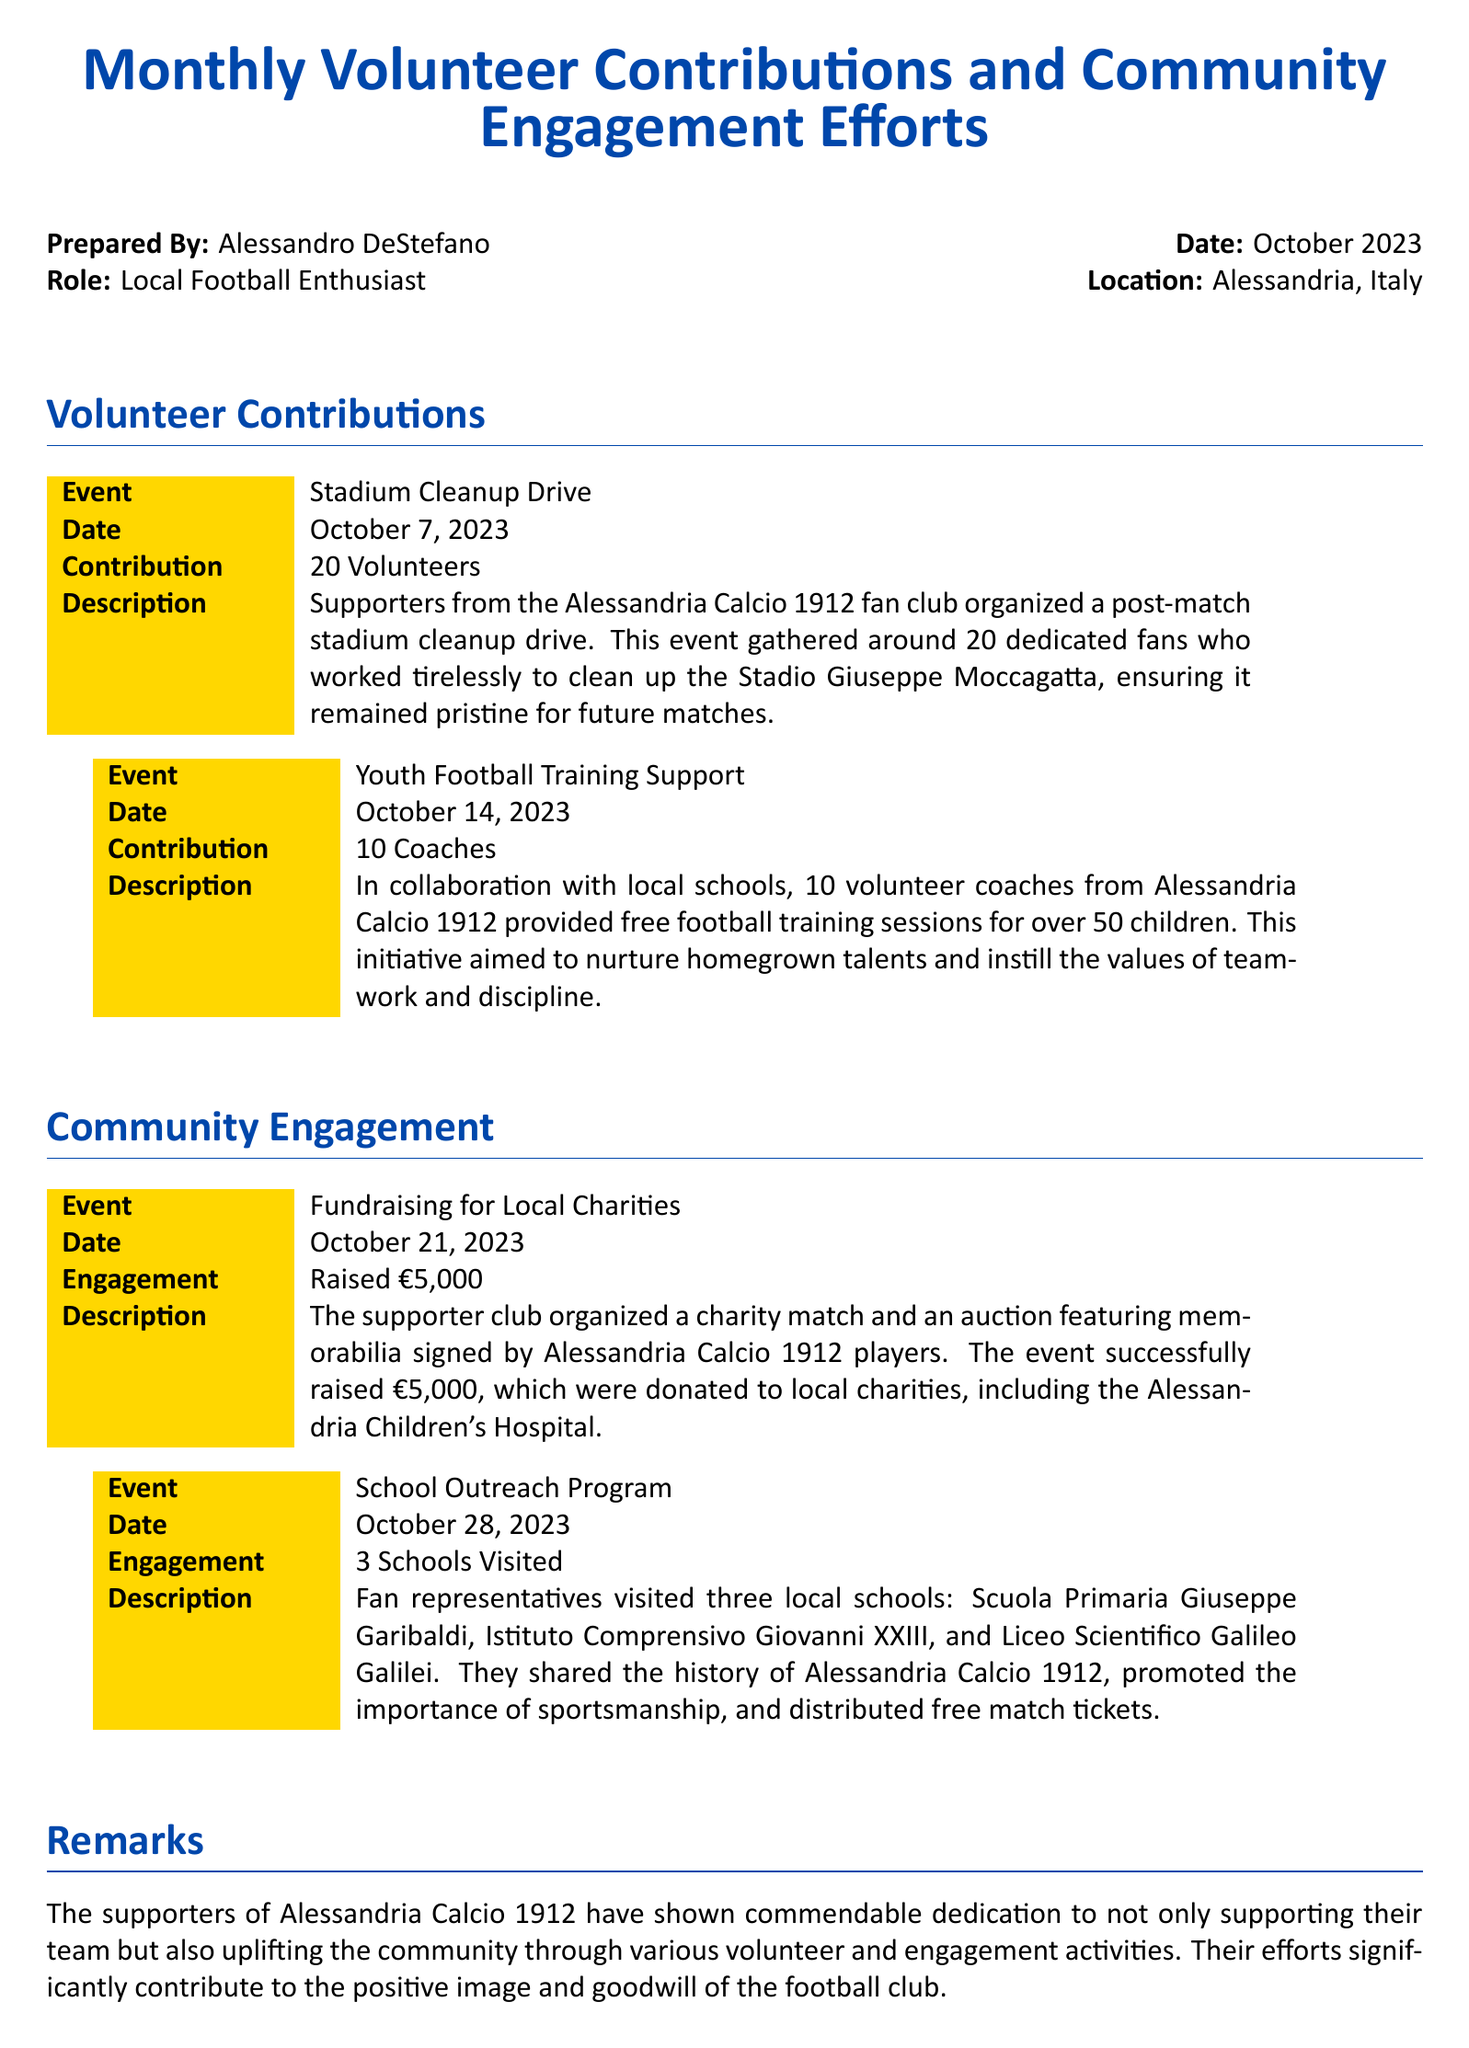what was the date of the stadium cleanup drive? The date of the stadium cleanup drive is specified in the document as October 7, 2023.
Answer: October 7, 2023 how many volunteers participated in the youth football training support? The document states that 10 coaches volunteered for the youth football training support.
Answer: 10 Coaches what amount was raised during the fundraising for local charities? The document indicates that the fundraising event raised €5,000.
Answer: €5,000 which football club do the supporters mentioned in the document belong to? The supporters mentioned in the document belong to Alessandria Calcio 1912.
Answer: Alessandria Calcio 1912 how many schools were visited during the school outreach program? The document specifies that three schools were visited during the outreach program.
Answer: 3 Schools Visited what type of event was organized to raise money for local charities? The document describes the event as a charity match and auction featuring memorabilia.
Answer: Charity match and auction what is the purpose of the youth football training support initiative? The initiative aims to nurture homegrown talents and instill teamwork and discipline.
Answer: Nurture homegrown talents who prepared the appraisal document? The appraisal document was prepared by Alessandro DeStefano.
Answer: Alessandro DeStefano 